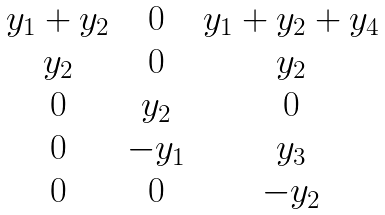Convert formula to latex. <formula><loc_0><loc_0><loc_500><loc_500>\begin{matrix} y _ { 1 } + y _ { 2 } & 0 & y _ { 1 } + y _ { 2 } + y _ { 4 } \\ y _ { 2 } & 0 & y _ { 2 } \\ 0 & y _ { 2 } & 0 \\ 0 & - y _ { 1 } & y _ { 3 } \\ 0 & 0 & - y _ { 2 } \end{matrix}</formula> 